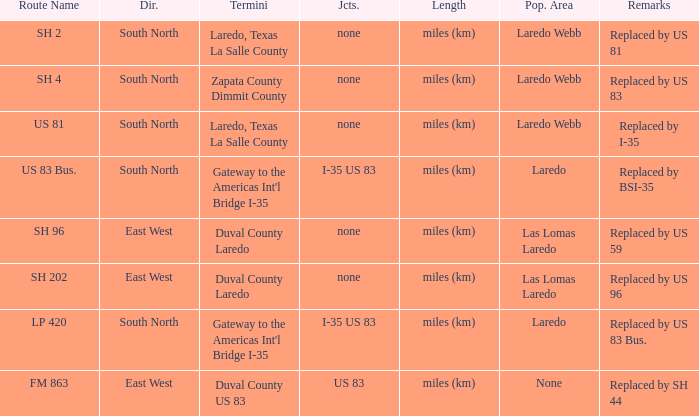Which population areas have "replaced by us 83" listed in their remarks section? Laredo Webb. 